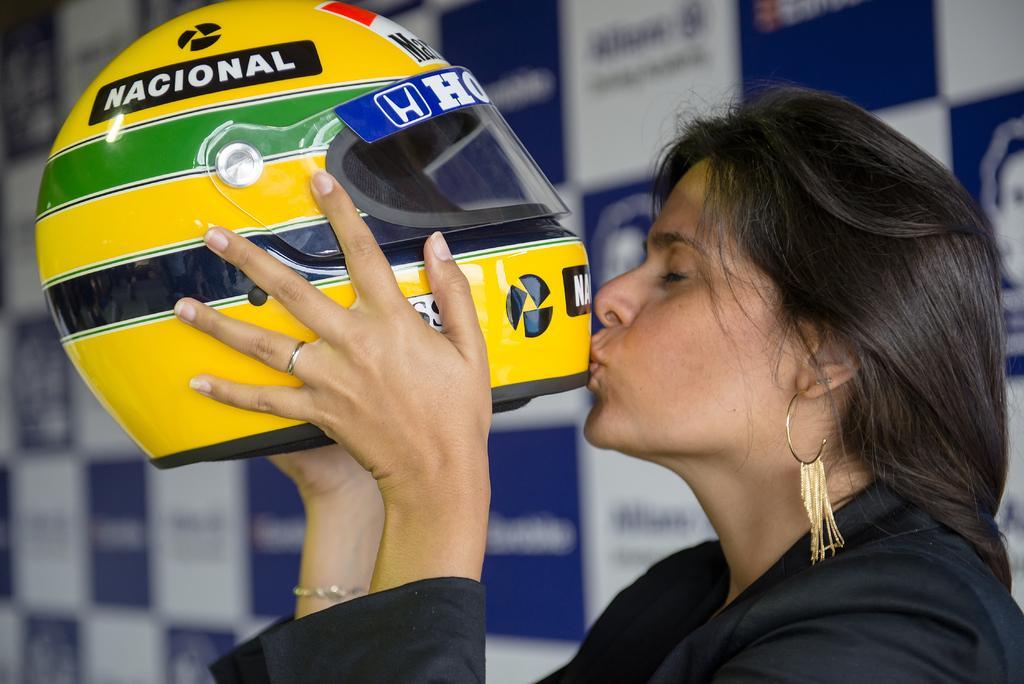In one or two sentences, can you explain what this image depicts? There is one woman wearing black color dress and holding a helmet as we can see in the middle of this image, and there is a wall poster in the background. 